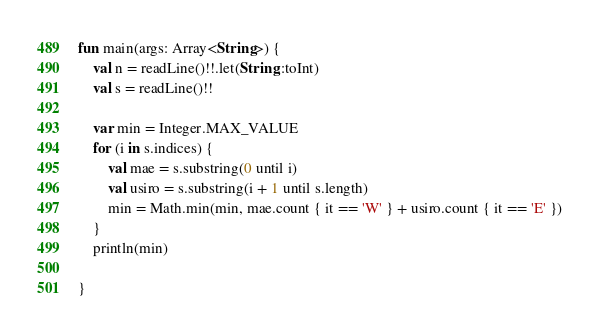Convert code to text. <code><loc_0><loc_0><loc_500><loc_500><_Kotlin_>fun main(args: Array<String>) {
    val n = readLine()!!.let(String::toInt)
    val s = readLine()!!

    var min = Integer.MAX_VALUE
    for (i in s.indices) {
        val mae = s.substring(0 until i)
        val usiro = s.substring(i + 1 until s.length)
        min = Math.min(min, mae.count { it == 'W' } + usiro.count { it == 'E' })
    }
    println(min)

}</code> 